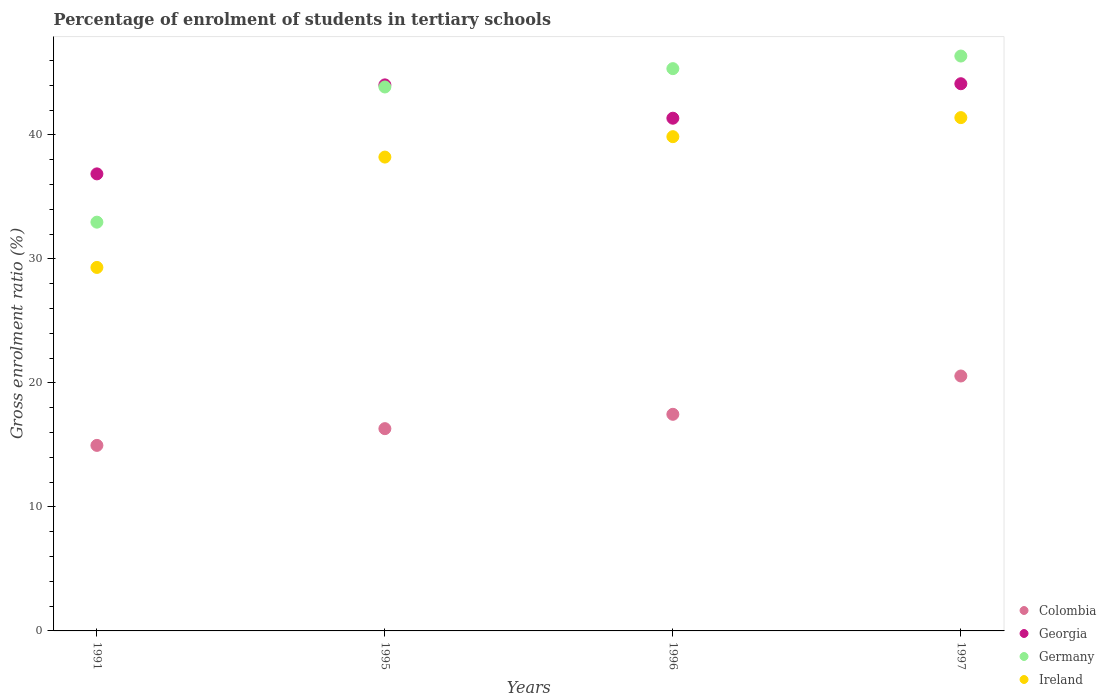How many different coloured dotlines are there?
Offer a terse response. 4. Is the number of dotlines equal to the number of legend labels?
Provide a short and direct response. Yes. What is the percentage of students enrolled in tertiary schools in Ireland in 1997?
Keep it short and to the point. 41.4. Across all years, what is the maximum percentage of students enrolled in tertiary schools in Georgia?
Make the answer very short. 44.13. Across all years, what is the minimum percentage of students enrolled in tertiary schools in Germany?
Ensure brevity in your answer.  32.96. In which year was the percentage of students enrolled in tertiary schools in Ireland minimum?
Provide a succinct answer. 1991. What is the total percentage of students enrolled in tertiary schools in Ireland in the graph?
Keep it short and to the point. 148.78. What is the difference between the percentage of students enrolled in tertiary schools in Germany in 1991 and that in 1995?
Your answer should be compact. -10.9. What is the difference between the percentage of students enrolled in tertiary schools in Colombia in 1991 and the percentage of students enrolled in tertiary schools in Germany in 1997?
Ensure brevity in your answer.  -31.4. What is the average percentage of students enrolled in tertiary schools in Germany per year?
Your answer should be very brief. 42.13. In the year 1997, what is the difference between the percentage of students enrolled in tertiary schools in Ireland and percentage of students enrolled in tertiary schools in Germany?
Provide a short and direct response. -4.97. In how many years, is the percentage of students enrolled in tertiary schools in Germany greater than 14 %?
Offer a very short reply. 4. What is the ratio of the percentage of students enrolled in tertiary schools in Germany in 1996 to that in 1997?
Offer a very short reply. 0.98. Is the difference between the percentage of students enrolled in tertiary schools in Ireland in 1991 and 1996 greater than the difference between the percentage of students enrolled in tertiary schools in Germany in 1991 and 1996?
Offer a terse response. Yes. What is the difference between the highest and the second highest percentage of students enrolled in tertiary schools in Ireland?
Provide a succinct answer. 1.54. What is the difference between the highest and the lowest percentage of students enrolled in tertiary schools in Georgia?
Make the answer very short. 7.27. Is the sum of the percentage of students enrolled in tertiary schools in Georgia in 1995 and 1996 greater than the maximum percentage of students enrolled in tertiary schools in Ireland across all years?
Offer a terse response. Yes. Is it the case that in every year, the sum of the percentage of students enrolled in tertiary schools in Ireland and percentage of students enrolled in tertiary schools in Georgia  is greater than the sum of percentage of students enrolled in tertiary schools in Colombia and percentage of students enrolled in tertiary schools in Germany?
Your answer should be compact. No. Is it the case that in every year, the sum of the percentage of students enrolled in tertiary schools in Georgia and percentage of students enrolled in tertiary schools in Ireland  is greater than the percentage of students enrolled in tertiary schools in Colombia?
Your answer should be very brief. Yes. Does the percentage of students enrolled in tertiary schools in Georgia monotonically increase over the years?
Offer a very short reply. No. Is the percentage of students enrolled in tertiary schools in Georgia strictly greater than the percentage of students enrolled in tertiary schools in Germany over the years?
Your response must be concise. No. Is the percentage of students enrolled in tertiary schools in Ireland strictly less than the percentage of students enrolled in tertiary schools in Germany over the years?
Offer a very short reply. Yes. How many years are there in the graph?
Keep it short and to the point. 4. Are the values on the major ticks of Y-axis written in scientific E-notation?
Provide a succinct answer. No. Does the graph contain any zero values?
Your response must be concise. No. Does the graph contain grids?
Ensure brevity in your answer.  No. Where does the legend appear in the graph?
Your answer should be very brief. Bottom right. How many legend labels are there?
Provide a succinct answer. 4. How are the legend labels stacked?
Your response must be concise. Vertical. What is the title of the graph?
Keep it short and to the point. Percentage of enrolment of students in tertiary schools. What is the label or title of the X-axis?
Offer a terse response. Years. What is the label or title of the Y-axis?
Provide a succinct answer. Gross enrolment ratio (%). What is the Gross enrolment ratio (%) in Colombia in 1991?
Provide a short and direct response. 14.96. What is the Gross enrolment ratio (%) in Georgia in 1991?
Offer a very short reply. 36.86. What is the Gross enrolment ratio (%) of Germany in 1991?
Your response must be concise. 32.96. What is the Gross enrolment ratio (%) in Ireland in 1991?
Provide a short and direct response. 29.31. What is the Gross enrolment ratio (%) in Colombia in 1995?
Make the answer very short. 16.31. What is the Gross enrolment ratio (%) of Georgia in 1995?
Offer a terse response. 44.04. What is the Gross enrolment ratio (%) of Germany in 1995?
Your response must be concise. 43.87. What is the Gross enrolment ratio (%) in Ireland in 1995?
Give a very brief answer. 38.21. What is the Gross enrolment ratio (%) in Colombia in 1996?
Keep it short and to the point. 17.47. What is the Gross enrolment ratio (%) of Georgia in 1996?
Your answer should be very brief. 41.35. What is the Gross enrolment ratio (%) in Germany in 1996?
Provide a short and direct response. 45.35. What is the Gross enrolment ratio (%) in Ireland in 1996?
Ensure brevity in your answer.  39.86. What is the Gross enrolment ratio (%) in Colombia in 1997?
Offer a terse response. 20.56. What is the Gross enrolment ratio (%) of Georgia in 1997?
Make the answer very short. 44.13. What is the Gross enrolment ratio (%) of Germany in 1997?
Offer a very short reply. 46.36. What is the Gross enrolment ratio (%) of Ireland in 1997?
Offer a very short reply. 41.4. Across all years, what is the maximum Gross enrolment ratio (%) of Colombia?
Provide a succinct answer. 20.56. Across all years, what is the maximum Gross enrolment ratio (%) in Georgia?
Provide a short and direct response. 44.13. Across all years, what is the maximum Gross enrolment ratio (%) in Germany?
Your response must be concise. 46.36. Across all years, what is the maximum Gross enrolment ratio (%) in Ireland?
Provide a succinct answer. 41.4. Across all years, what is the minimum Gross enrolment ratio (%) of Colombia?
Your response must be concise. 14.96. Across all years, what is the minimum Gross enrolment ratio (%) in Georgia?
Offer a terse response. 36.86. Across all years, what is the minimum Gross enrolment ratio (%) in Germany?
Ensure brevity in your answer.  32.96. Across all years, what is the minimum Gross enrolment ratio (%) in Ireland?
Offer a terse response. 29.31. What is the total Gross enrolment ratio (%) in Colombia in the graph?
Keep it short and to the point. 69.3. What is the total Gross enrolment ratio (%) in Georgia in the graph?
Your answer should be very brief. 166.37. What is the total Gross enrolment ratio (%) of Germany in the graph?
Your answer should be compact. 168.54. What is the total Gross enrolment ratio (%) in Ireland in the graph?
Your response must be concise. 148.78. What is the difference between the Gross enrolment ratio (%) of Colombia in 1991 and that in 1995?
Your answer should be compact. -1.35. What is the difference between the Gross enrolment ratio (%) in Georgia in 1991 and that in 1995?
Your answer should be very brief. -7.18. What is the difference between the Gross enrolment ratio (%) of Germany in 1991 and that in 1995?
Offer a terse response. -10.9. What is the difference between the Gross enrolment ratio (%) of Ireland in 1991 and that in 1995?
Your answer should be very brief. -8.9. What is the difference between the Gross enrolment ratio (%) of Colombia in 1991 and that in 1996?
Provide a succinct answer. -2.51. What is the difference between the Gross enrolment ratio (%) in Georgia in 1991 and that in 1996?
Provide a short and direct response. -4.49. What is the difference between the Gross enrolment ratio (%) of Germany in 1991 and that in 1996?
Provide a short and direct response. -12.38. What is the difference between the Gross enrolment ratio (%) in Ireland in 1991 and that in 1996?
Provide a succinct answer. -10.54. What is the difference between the Gross enrolment ratio (%) of Colombia in 1991 and that in 1997?
Make the answer very short. -5.6. What is the difference between the Gross enrolment ratio (%) of Georgia in 1991 and that in 1997?
Offer a very short reply. -7.27. What is the difference between the Gross enrolment ratio (%) in Germany in 1991 and that in 1997?
Your answer should be very brief. -13.4. What is the difference between the Gross enrolment ratio (%) of Ireland in 1991 and that in 1997?
Offer a very short reply. -12.08. What is the difference between the Gross enrolment ratio (%) in Colombia in 1995 and that in 1996?
Keep it short and to the point. -1.16. What is the difference between the Gross enrolment ratio (%) of Georgia in 1995 and that in 1996?
Offer a very short reply. 2.69. What is the difference between the Gross enrolment ratio (%) of Germany in 1995 and that in 1996?
Offer a terse response. -1.48. What is the difference between the Gross enrolment ratio (%) of Ireland in 1995 and that in 1996?
Your answer should be very brief. -1.65. What is the difference between the Gross enrolment ratio (%) in Colombia in 1995 and that in 1997?
Ensure brevity in your answer.  -4.25. What is the difference between the Gross enrolment ratio (%) in Georgia in 1995 and that in 1997?
Offer a terse response. -0.09. What is the difference between the Gross enrolment ratio (%) of Germany in 1995 and that in 1997?
Give a very brief answer. -2.49. What is the difference between the Gross enrolment ratio (%) in Ireland in 1995 and that in 1997?
Your answer should be compact. -3.18. What is the difference between the Gross enrolment ratio (%) in Colombia in 1996 and that in 1997?
Your answer should be very brief. -3.09. What is the difference between the Gross enrolment ratio (%) of Georgia in 1996 and that in 1997?
Give a very brief answer. -2.78. What is the difference between the Gross enrolment ratio (%) of Germany in 1996 and that in 1997?
Provide a short and direct response. -1.02. What is the difference between the Gross enrolment ratio (%) in Ireland in 1996 and that in 1997?
Offer a very short reply. -1.54. What is the difference between the Gross enrolment ratio (%) of Colombia in 1991 and the Gross enrolment ratio (%) of Georgia in 1995?
Make the answer very short. -29.07. What is the difference between the Gross enrolment ratio (%) of Colombia in 1991 and the Gross enrolment ratio (%) of Germany in 1995?
Your answer should be compact. -28.9. What is the difference between the Gross enrolment ratio (%) in Colombia in 1991 and the Gross enrolment ratio (%) in Ireland in 1995?
Offer a very short reply. -23.25. What is the difference between the Gross enrolment ratio (%) in Georgia in 1991 and the Gross enrolment ratio (%) in Germany in 1995?
Give a very brief answer. -7.01. What is the difference between the Gross enrolment ratio (%) of Georgia in 1991 and the Gross enrolment ratio (%) of Ireland in 1995?
Your response must be concise. -1.35. What is the difference between the Gross enrolment ratio (%) in Germany in 1991 and the Gross enrolment ratio (%) in Ireland in 1995?
Offer a terse response. -5.25. What is the difference between the Gross enrolment ratio (%) of Colombia in 1991 and the Gross enrolment ratio (%) of Georgia in 1996?
Give a very brief answer. -26.39. What is the difference between the Gross enrolment ratio (%) of Colombia in 1991 and the Gross enrolment ratio (%) of Germany in 1996?
Make the answer very short. -30.38. What is the difference between the Gross enrolment ratio (%) in Colombia in 1991 and the Gross enrolment ratio (%) in Ireland in 1996?
Offer a very short reply. -24.9. What is the difference between the Gross enrolment ratio (%) of Georgia in 1991 and the Gross enrolment ratio (%) of Germany in 1996?
Provide a succinct answer. -8.49. What is the difference between the Gross enrolment ratio (%) in Georgia in 1991 and the Gross enrolment ratio (%) in Ireland in 1996?
Offer a very short reply. -3. What is the difference between the Gross enrolment ratio (%) of Germany in 1991 and the Gross enrolment ratio (%) of Ireland in 1996?
Give a very brief answer. -6.89. What is the difference between the Gross enrolment ratio (%) of Colombia in 1991 and the Gross enrolment ratio (%) of Georgia in 1997?
Ensure brevity in your answer.  -29.17. What is the difference between the Gross enrolment ratio (%) of Colombia in 1991 and the Gross enrolment ratio (%) of Germany in 1997?
Your response must be concise. -31.4. What is the difference between the Gross enrolment ratio (%) in Colombia in 1991 and the Gross enrolment ratio (%) in Ireland in 1997?
Provide a succinct answer. -26.43. What is the difference between the Gross enrolment ratio (%) of Georgia in 1991 and the Gross enrolment ratio (%) of Germany in 1997?
Your answer should be compact. -9.5. What is the difference between the Gross enrolment ratio (%) of Georgia in 1991 and the Gross enrolment ratio (%) of Ireland in 1997?
Offer a terse response. -4.54. What is the difference between the Gross enrolment ratio (%) of Germany in 1991 and the Gross enrolment ratio (%) of Ireland in 1997?
Keep it short and to the point. -8.43. What is the difference between the Gross enrolment ratio (%) of Colombia in 1995 and the Gross enrolment ratio (%) of Georgia in 1996?
Offer a very short reply. -25.04. What is the difference between the Gross enrolment ratio (%) in Colombia in 1995 and the Gross enrolment ratio (%) in Germany in 1996?
Your answer should be compact. -29.03. What is the difference between the Gross enrolment ratio (%) in Colombia in 1995 and the Gross enrolment ratio (%) in Ireland in 1996?
Provide a short and direct response. -23.55. What is the difference between the Gross enrolment ratio (%) in Georgia in 1995 and the Gross enrolment ratio (%) in Germany in 1996?
Keep it short and to the point. -1.31. What is the difference between the Gross enrolment ratio (%) of Georgia in 1995 and the Gross enrolment ratio (%) of Ireland in 1996?
Your answer should be very brief. 4.18. What is the difference between the Gross enrolment ratio (%) in Germany in 1995 and the Gross enrolment ratio (%) in Ireland in 1996?
Offer a very short reply. 4.01. What is the difference between the Gross enrolment ratio (%) of Colombia in 1995 and the Gross enrolment ratio (%) of Georgia in 1997?
Provide a succinct answer. -27.82. What is the difference between the Gross enrolment ratio (%) in Colombia in 1995 and the Gross enrolment ratio (%) in Germany in 1997?
Your response must be concise. -30.05. What is the difference between the Gross enrolment ratio (%) of Colombia in 1995 and the Gross enrolment ratio (%) of Ireland in 1997?
Your answer should be very brief. -25.08. What is the difference between the Gross enrolment ratio (%) in Georgia in 1995 and the Gross enrolment ratio (%) in Germany in 1997?
Ensure brevity in your answer.  -2.33. What is the difference between the Gross enrolment ratio (%) of Georgia in 1995 and the Gross enrolment ratio (%) of Ireland in 1997?
Your answer should be very brief. 2.64. What is the difference between the Gross enrolment ratio (%) in Germany in 1995 and the Gross enrolment ratio (%) in Ireland in 1997?
Your response must be concise. 2.47. What is the difference between the Gross enrolment ratio (%) in Colombia in 1996 and the Gross enrolment ratio (%) in Georgia in 1997?
Your answer should be compact. -26.66. What is the difference between the Gross enrolment ratio (%) in Colombia in 1996 and the Gross enrolment ratio (%) in Germany in 1997?
Make the answer very short. -28.89. What is the difference between the Gross enrolment ratio (%) of Colombia in 1996 and the Gross enrolment ratio (%) of Ireland in 1997?
Your answer should be very brief. -23.93. What is the difference between the Gross enrolment ratio (%) of Georgia in 1996 and the Gross enrolment ratio (%) of Germany in 1997?
Provide a succinct answer. -5.01. What is the difference between the Gross enrolment ratio (%) in Georgia in 1996 and the Gross enrolment ratio (%) in Ireland in 1997?
Give a very brief answer. -0.05. What is the difference between the Gross enrolment ratio (%) of Germany in 1996 and the Gross enrolment ratio (%) of Ireland in 1997?
Keep it short and to the point. 3.95. What is the average Gross enrolment ratio (%) of Colombia per year?
Ensure brevity in your answer.  17.33. What is the average Gross enrolment ratio (%) of Georgia per year?
Provide a short and direct response. 41.59. What is the average Gross enrolment ratio (%) of Germany per year?
Provide a short and direct response. 42.13. What is the average Gross enrolment ratio (%) of Ireland per year?
Provide a short and direct response. 37.2. In the year 1991, what is the difference between the Gross enrolment ratio (%) in Colombia and Gross enrolment ratio (%) in Georgia?
Provide a short and direct response. -21.9. In the year 1991, what is the difference between the Gross enrolment ratio (%) of Colombia and Gross enrolment ratio (%) of Germany?
Your response must be concise. -18. In the year 1991, what is the difference between the Gross enrolment ratio (%) of Colombia and Gross enrolment ratio (%) of Ireland?
Your answer should be very brief. -14.35. In the year 1991, what is the difference between the Gross enrolment ratio (%) in Georgia and Gross enrolment ratio (%) in Germany?
Ensure brevity in your answer.  3.89. In the year 1991, what is the difference between the Gross enrolment ratio (%) of Georgia and Gross enrolment ratio (%) of Ireland?
Make the answer very short. 7.54. In the year 1991, what is the difference between the Gross enrolment ratio (%) of Germany and Gross enrolment ratio (%) of Ireland?
Offer a very short reply. 3.65. In the year 1995, what is the difference between the Gross enrolment ratio (%) in Colombia and Gross enrolment ratio (%) in Georgia?
Provide a short and direct response. -27.72. In the year 1995, what is the difference between the Gross enrolment ratio (%) of Colombia and Gross enrolment ratio (%) of Germany?
Your answer should be very brief. -27.55. In the year 1995, what is the difference between the Gross enrolment ratio (%) of Colombia and Gross enrolment ratio (%) of Ireland?
Provide a short and direct response. -21.9. In the year 1995, what is the difference between the Gross enrolment ratio (%) of Georgia and Gross enrolment ratio (%) of Germany?
Provide a short and direct response. 0.17. In the year 1995, what is the difference between the Gross enrolment ratio (%) in Georgia and Gross enrolment ratio (%) in Ireland?
Offer a very short reply. 5.82. In the year 1995, what is the difference between the Gross enrolment ratio (%) in Germany and Gross enrolment ratio (%) in Ireland?
Make the answer very short. 5.65. In the year 1996, what is the difference between the Gross enrolment ratio (%) in Colombia and Gross enrolment ratio (%) in Georgia?
Provide a succinct answer. -23.88. In the year 1996, what is the difference between the Gross enrolment ratio (%) of Colombia and Gross enrolment ratio (%) of Germany?
Ensure brevity in your answer.  -27.88. In the year 1996, what is the difference between the Gross enrolment ratio (%) of Colombia and Gross enrolment ratio (%) of Ireland?
Your response must be concise. -22.39. In the year 1996, what is the difference between the Gross enrolment ratio (%) of Georgia and Gross enrolment ratio (%) of Germany?
Provide a short and direct response. -4. In the year 1996, what is the difference between the Gross enrolment ratio (%) of Georgia and Gross enrolment ratio (%) of Ireland?
Offer a terse response. 1.49. In the year 1996, what is the difference between the Gross enrolment ratio (%) of Germany and Gross enrolment ratio (%) of Ireland?
Your response must be concise. 5.49. In the year 1997, what is the difference between the Gross enrolment ratio (%) of Colombia and Gross enrolment ratio (%) of Georgia?
Your answer should be very brief. -23.57. In the year 1997, what is the difference between the Gross enrolment ratio (%) in Colombia and Gross enrolment ratio (%) in Germany?
Ensure brevity in your answer.  -25.8. In the year 1997, what is the difference between the Gross enrolment ratio (%) in Colombia and Gross enrolment ratio (%) in Ireland?
Your response must be concise. -20.84. In the year 1997, what is the difference between the Gross enrolment ratio (%) in Georgia and Gross enrolment ratio (%) in Germany?
Your answer should be compact. -2.23. In the year 1997, what is the difference between the Gross enrolment ratio (%) of Georgia and Gross enrolment ratio (%) of Ireland?
Ensure brevity in your answer.  2.73. In the year 1997, what is the difference between the Gross enrolment ratio (%) in Germany and Gross enrolment ratio (%) in Ireland?
Offer a very short reply. 4.97. What is the ratio of the Gross enrolment ratio (%) in Colombia in 1991 to that in 1995?
Provide a short and direct response. 0.92. What is the ratio of the Gross enrolment ratio (%) in Georgia in 1991 to that in 1995?
Offer a terse response. 0.84. What is the ratio of the Gross enrolment ratio (%) in Germany in 1991 to that in 1995?
Make the answer very short. 0.75. What is the ratio of the Gross enrolment ratio (%) of Ireland in 1991 to that in 1995?
Offer a very short reply. 0.77. What is the ratio of the Gross enrolment ratio (%) in Colombia in 1991 to that in 1996?
Provide a short and direct response. 0.86. What is the ratio of the Gross enrolment ratio (%) of Georgia in 1991 to that in 1996?
Offer a very short reply. 0.89. What is the ratio of the Gross enrolment ratio (%) of Germany in 1991 to that in 1996?
Give a very brief answer. 0.73. What is the ratio of the Gross enrolment ratio (%) of Ireland in 1991 to that in 1996?
Ensure brevity in your answer.  0.74. What is the ratio of the Gross enrolment ratio (%) of Colombia in 1991 to that in 1997?
Your response must be concise. 0.73. What is the ratio of the Gross enrolment ratio (%) of Georgia in 1991 to that in 1997?
Your response must be concise. 0.84. What is the ratio of the Gross enrolment ratio (%) of Germany in 1991 to that in 1997?
Make the answer very short. 0.71. What is the ratio of the Gross enrolment ratio (%) in Ireland in 1991 to that in 1997?
Give a very brief answer. 0.71. What is the ratio of the Gross enrolment ratio (%) in Colombia in 1995 to that in 1996?
Keep it short and to the point. 0.93. What is the ratio of the Gross enrolment ratio (%) in Georgia in 1995 to that in 1996?
Ensure brevity in your answer.  1.06. What is the ratio of the Gross enrolment ratio (%) in Germany in 1995 to that in 1996?
Your response must be concise. 0.97. What is the ratio of the Gross enrolment ratio (%) of Ireland in 1995 to that in 1996?
Keep it short and to the point. 0.96. What is the ratio of the Gross enrolment ratio (%) of Colombia in 1995 to that in 1997?
Offer a terse response. 0.79. What is the ratio of the Gross enrolment ratio (%) in Georgia in 1995 to that in 1997?
Provide a succinct answer. 1. What is the ratio of the Gross enrolment ratio (%) in Germany in 1995 to that in 1997?
Your response must be concise. 0.95. What is the ratio of the Gross enrolment ratio (%) in Colombia in 1996 to that in 1997?
Offer a terse response. 0.85. What is the ratio of the Gross enrolment ratio (%) of Georgia in 1996 to that in 1997?
Ensure brevity in your answer.  0.94. What is the ratio of the Gross enrolment ratio (%) in Germany in 1996 to that in 1997?
Make the answer very short. 0.98. What is the ratio of the Gross enrolment ratio (%) in Ireland in 1996 to that in 1997?
Provide a succinct answer. 0.96. What is the difference between the highest and the second highest Gross enrolment ratio (%) of Colombia?
Offer a terse response. 3.09. What is the difference between the highest and the second highest Gross enrolment ratio (%) of Georgia?
Keep it short and to the point. 0.09. What is the difference between the highest and the second highest Gross enrolment ratio (%) in Ireland?
Your answer should be very brief. 1.54. What is the difference between the highest and the lowest Gross enrolment ratio (%) in Colombia?
Provide a succinct answer. 5.6. What is the difference between the highest and the lowest Gross enrolment ratio (%) of Georgia?
Give a very brief answer. 7.27. What is the difference between the highest and the lowest Gross enrolment ratio (%) in Germany?
Your response must be concise. 13.4. What is the difference between the highest and the lowest Gross enrolment ratio (%) of Ireland?
Provide a succinct answer. 12.08. 